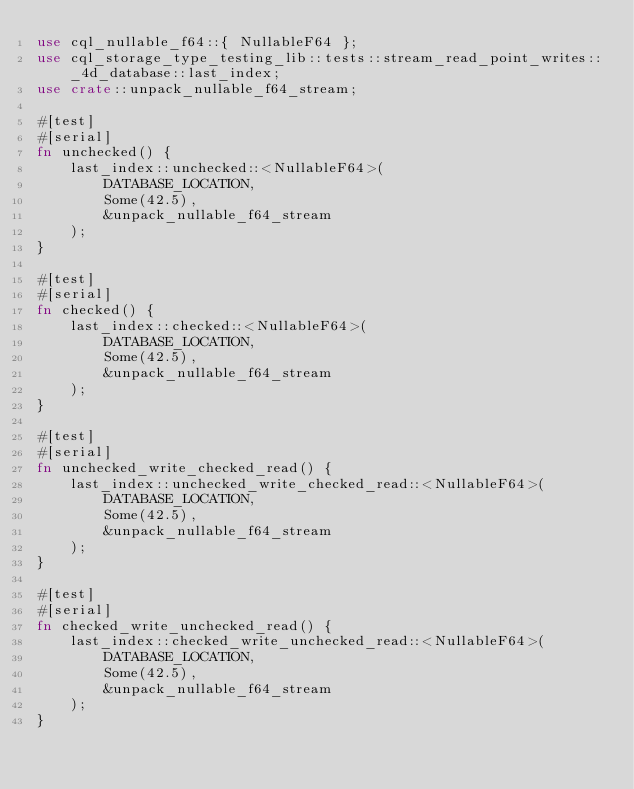Convert code to text. <code><loc_0><loc_0><loc_500><loc_500><_Rust_>use cql_nullable_f64::{ NullableF64 };
use cql_storage_type_testing_lib::tests::stream_read_point_writes::_4d_database::last_index;
use crate::unpack_nullable_f64_stream;

#[test]
#[serial]
fn unchecked() {
    last_index::unchecked::<NullableF64>(
        DATABASE_LOCATION,
        Some(42.5),
        &unpack_nullable_f64_stream
    );
}

#[test]
#[serial]
fn checked() {
    last_index::checked::<NullableF64>(
        DATABASE_LOCATION,
        Some(42.5),
        &unpack_nullable_f64_stream
    );
}

#[test]
#[serial]
fn unchecked_write_checked_read() {
    last_index::unchecked_write_checked_read::<NullableF64>(
        DATABASE_LOCATION,
        Some(42.5),
        &unpack_nullable_f64_stream
    );
}

#[test]
#[serial]
fn checked_write_unchecked_read() {
    last_index::checked_write_unchecked_read::<NullableF64>(
        DATABASE_LOCATION,
        Some(42.5),
        &unpack_nullable_f64_stream
    );
}
</code> 